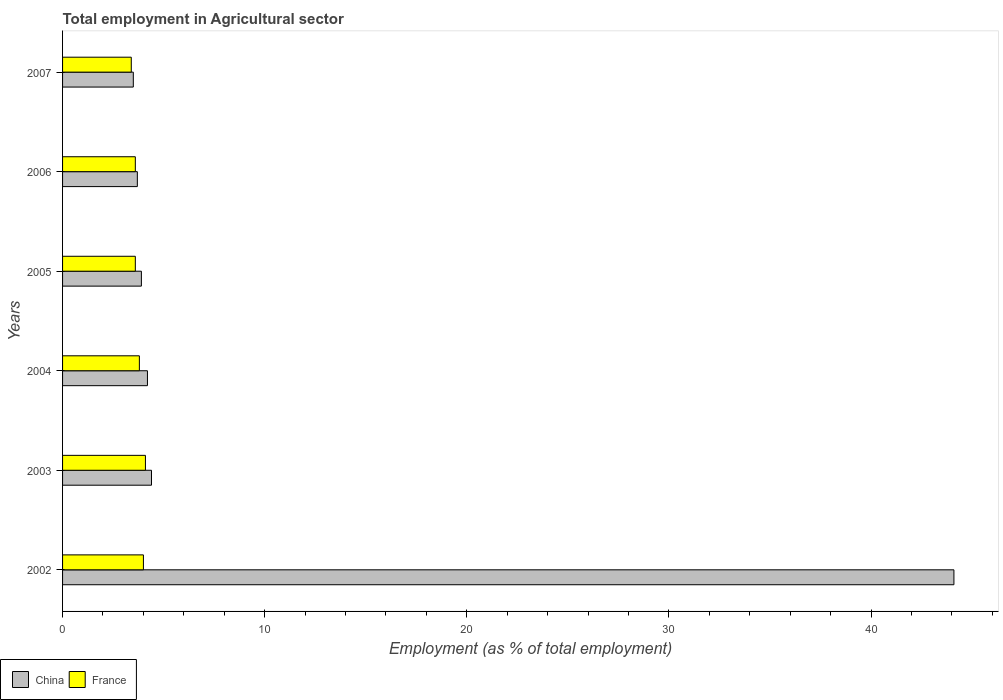How many different coloured bars are there?
Provide a short and direct response. 2. How many groups of bars are there?
Make the answer very short. 6. How many bars are there on the 6th tick from the top?
Make the answer very short. 2. How many bars are there on the 2nd tick from the bottom?
Offer a very short reply. 2. What is the label of the 3rd group of bars from the top?
Your answer should be very brief. 2005. In how many cases, is the number of bars for a given year not equal to the number of legend labels?
Keep it short and to the point. 0. What is the employment in agricultural sector in China in 2002?
Provide a short and direct response. 44.1. Across all years, what is the maximum employment in agricultural sector in France?
Offer a terse response. 4.1. Across all years, what is the minimum employment in agricultural sector in China?
Your answer should be very brief. 3.5. In which year was the employment in agricultural sector in France minimum?
Offer a very short reply. 2007. What is the total employment in agricultural sector in France in the graph?
Give a very brief answer. 22.5. What is the difference between the employment in agricultural sector in France in 2002 and that in 2005?
Your answer should be compact. 0.4. What is the difference between the employment in agricultural sector in France in 2007 and the employment in agricultural sector in China in 2002?
Keep it short and to the point. -40.7. What is the average employment in agricultural sector in China per year?
Ensure brevity in your answer.  10.63. In the year 2007, what is the difference between the employment in agricultural sector in France and employment in agricultural sector in China?
Your answer should be very brief. -0.1. What is the ratio of the employment in agricultural sector in China in 2004 to that in 2006?
Your response must be concise. 1.14. Is the employment in agricultural sector in France in 2005 less than that in 2006?
Offer a terse response. No. Is the difference between the employment in agricultural sector in France in 2006 and 2007 greater than the difference between the employment in agricultural sector in China in 2006 and 2007?
Offer a very short reply. No. What is the difference between the highest and the second highest employment in agricultural sector in China?
Offer a very short reply. 39.7. What is the difference between the highest and the lowest employment in agricultural sector in France?
Make the answer very short. 0.7. Is the sum of the employment in agricultural sector in France in 2002 and 2003 greater than the maximum employment in agricultural sector in China across all years?
Offer a very short reply. No. What does the 1st bar from the bottom in 2005 represents?
Offer a very short reply. China. Are the values on the major ticks of X-axis written in scientific E-notation?
Provide a succinct answer. No. Does the graph contain grids?
Your answer should be very brief. No. Where does the legend appear in the graph?
Offer a terse response. Bottom left. How many legend labels are there?
Keep it short and to the point. 2. How are the legend labels stacked?
Provide a succinct answer. Horizontal. What is the title of the graph?
Offer a very short reply. Total employment in Agricultural sector. Does "Latin America(all income levels)" appear as one of the legend labels in the graph?
Make the answer very short. No. What is the label or title of the X-axis?
Ensure brevity in your answer.  Employment (as % of total employment). What is the Employment (as % of total employment) of China in 2002?
Your answer should be compact. 44.1. What is the Employment (as % of total employment) of China in 2003?
Provide a succinct answer. 4.4. What is the Employment (as % of total employment) of France in 2003?
Give a very brief answer. 4.1. What is the Employment (as % of total employment) of China in 2004?
Give a very brief answer. 4.2. What is the Employment (as % of total employment) in France in 2004?
Offer a very short reply. 3.8. What is the Employment (as % of total employment) of China in 2005?
Provide a short and direct response. 3.9. What is the Employment (as % of total employment) of France in 2005?
Provide a short and direct response. 3.6. What is the Employment (as % of total employment) of China in 2006?
Provide a short and direct response. 3.7. What is the Employment (as % of total employment) of France in 2006?
Keep it short and to the point. 3.6. What is the Employment (as % of total employment) in China in 2007?
Your answer should be very brief. 3.5. What is the Employment (as % of total employment) of France in 2007?
Make the answer very short. 3.4. Across all years, what is the maximum Employment (as % of total employment) of China?
Offer a terse response. 44.1. Across all years, what is the maximum Employment (as % of total employment) of France?
Your answer should be compact. 4.1. Across all years, what is the minimum Employment (as % of total employment) in China?
Offer a very short reply. 3.5. Across all years, what is the minimum Employment (as % of total employment) of France?
Ensure brevity in your answer.  3.4. What is the total Employment (as % of total employment) of China in the graph?
Offer a terse response. 63.8. What is the total Employment (as % of total employment) of France in the graph?
Keep it short and to the point. 22.5. What is the difference between the Employment (as % of total employment) of China in 2002 and that in 2003?
Your response must be concise. 39.7. What is the difference between the Employment (as % of total employment) of France in 2002 and that in 2003?
Provide a succinct answer. -0.1. What is the difference between the Employment (as % of total employment) in China in 2002 and that in 2004?
Your answer should be very brief. 39.9. What is the difference between the Employment (as % of total employment) of France in 2002 and that in 2004?
Your answer should be compact. 0.2. What is the difference between the Employment (as % of total employment) of China in 2002 and that in 2005?
Provide a short and direct response. 40.2. What is the difference between the Employment (as % of total employment) of China in 2002 and that in 2006?
Make the answer very short. 40.4. What is the difference between the Employment (as % of total employment) in China in 2002 and that in 2007?
Make the answer very short. 40.6. What is the difference between the Employment (as % of total employment) in France in 2002 and that in 2007?
Offer a terse response. 0.6. What is the difference between the Employment (as % of total employment) of France in 2003 and that in 2004?
Your response must be concise. 0.3. What is the difference between the Employment (as % of total employment) in China in 2003 and that in 2006?
Give a very brief answer. 0.7. What is the difference between the Employment (as % of total employment) in China in 2003 and that in 2007?
Your answer should be compact. 0.9. What is the difference between the Employment (as % of total employment) of France in 2003 and that in 2007?
Offer a very short reply. 0.7. What is the difference between the Employment (as % of total employment) in France in 2004 and that in 2005?
Your response must be concise. 0.2. What is the difference between the Employment (as % of total employment) in China in 2004 and that in 2006?
Your response must be concise. 0.5. What is the difference between the Employment (as % of total employment) in China in 2005 and that in 2006?
Keep it short and to the point. 0.2. What is the difference between the Employment (as % of total employment) in China in 2005 and that in 2007?
Provide a succinct answer. 0.4. What is the difference between the Employment (as % of total employment) of France in 2005 and that in 2007?
Keep it short and to the point. 0.2. What is the difference between the Employment (as % of total employment) of China in 2006 and that in 2007?
Your answer should be very brief. 0.2. What is the difference between the Employment (as % of total employment) in France in 2006 and that in 2007?
Offer a very short reply. 0.2. What is the difference between the Employment (as % of total employment) in China in 2002 and the Employment (as % of total employment) in France in 2003?
Give a very brief answer. 40. What is the difference between the Employment (as % of total employment) of China in 2002 and the Employment (as % of total employment) of France in 2004?
Your answer should be compact. 40.3. What is the difference between the Employment (as % of total employment) in China in 2002 and the Employment (as % of total employment) in France in 2005?
Your response must be concise. 40.5. What is the difference between the Employment (as % of total employment) in China in 2002 and the Employment (as % of total employment) in France in 2006?
Your answer should be very brief. 40.5. What is the difference between the Employment (as % of total employment) of China in 2002 and the Employment (as % of total employment) of France in 2007?
Provide a short and direct response. 40.7. What is the difference between the Employment (as % of total employment) in China in 2003 and the Employment (as % of total employment) in France in 2004?
Your answer should be compact. 0.6. What is the difference between the Employment (as % of total employment) in China in 2003 and the Employment (as % of total employment) in France in 2007?
Offer a terse response. 1. What is the difference between the Employment (as % of total employment) in China in 2004 and the Employment (as % of total employment) in France in 2006?
Offer a terse response. 0.6. What is the difference between the Employment (as % of total employment) in China in 2005 and the Employment (as % of total employment) in France in 2006?
Keep it short and to the point. 0.3. What is the difference between the Employment (as % of total employment) in China in 2005 and the Employment (as % of total employment) in France in 2007?
Offer a very short reply. 0.5. What is the average Employment (as % of total employment) of China per year?
Offer a terse response. 10.63. What is the average Employment (as % of total employment) of France per year?
Give a very brief answer. 3.75. In the year 2002, what is the difference between the Employment (as % of total employment) of China and Employment (as % of total employment) of France?
Keep it short and to the point. 40.1. In the year 2004, what is the difference between the Employment (as % of total employment) in China and Employment (as % of total employment) in France?
Provide a succinct answer. 0.4. In the year 2006, what is the difference between the Employment (as % of total employment) in China and Employment (as % of total employment) in France?
Provide a succinct answer. 0.1. In the year 2007, what is the difference between the Employment (as % of total employment) in China and Employment (as % of total employment) in France?
Keep it short and to the point. 0.1. What is the ratio of the Employment (as % of total employment) of China in 2002 to that in 2003?
Provide a succinct answer. 10.02. What is the ratio of the Employment (as % of total employment) of France in 2002 to that in 2003?
Provide a short and direct response. 0.98. What is the ratio of the Employment (as % of total employment) in China in 2002 to that in 2004?
Offer a terse response. 10.5. What is the ratio of the Employment (as % of total employment) of France in 2002 to that in 2004?
Keep it short and to the point. 1.05. What is the ratio of the Employment (as % of total employment) in China in 2002 to that in 2005?
Provide a succinct answer. 11.31. What is the ratio of the Employment (as % of total employment) in China in 2002 to that in 2006?
Offer a very short reply. 11.92. What is the ratio of the Employment (as % of total employment) of China in 2002 to that in 2007?
Your answer should be compact. 12.6. What is the ratio of the Employment (as % of total employment) of France in 2002 to that in 2007?
Your response must be concise. 1.18. What is the ratio of the Employment (as % of total employment) in China in 2003 to that in 2004?
Keep it short and to the point. 1.05. What is the ratio of the Employment (as % of total employment) in France in 2003 to that in 2004?
Provide a succinct answer. 1.08. What is the ratio of the Employment (as % of total employment) in China in 2003 to that in 2005?
Offer a terse response. 1.13. What is the ratio of the Employment (as % of total employment) of France in 2003 to that in 2005?
Ensure brevity in your answer.  1.14. What is the ratio of the Employment (as % of total employment) of China in 2003 to that in 2006?
Provide a short and direct response. 1.19. What is the ratio of the Employment (as % of total employment) of France in 2003 to that in 2006?
Make the answer very short. 1.14. What is the ratio of the Employment (as % of total employment) in China in 2003 to that in 2007?
Keep it short and to the point. 1.26. What is the ratio of the Employment (as % of total employment) of France in 2003 to that in 2007?
Give a very brief answer. 1.21. What is the ratio of the Employment (as % of total employment) in China in 2004 to that in 2005?
Give a very brief answer. 1.08. What is the ratio of the Employment (as % of total employment) of France in 2004 to that in 2005?
Your response must be concise. 1.06. What is the ratio of the Employment (as % of total employment) in China in 2004 to that in 2006?
Offer a terse response. 1.14. What is the ratio of the Employment (as % of total employment) of France in 2004 to that in 2006?
Provide a succinct answer. 1.06. What is the ratio of the Employment (as % of total employment) in France in 2004 to that in 2007?
Keep it short and to the point. 1.12. What is the ratio of the Employment (as % of total employment) of China in 2005 to that in 2006?
Offer a very short reply. 1.05. What is the ratio of the Employment (as % of total employment) of China in 2005 to that in 2007?
Give a very brief answer. 1.11. What is the ratio of the Employment (as % of total employment) of France in 2005 to that in 2007?
Offer a terse response. 1.06. What is the ratio of the Employment (as % of total employment) in China in 2006 to that in 2007?
Make the answer very short. 1.06. What is the ratio of the Employment (as % of total employment) in France in 2006 to that in 2007?
Your answer should be very brief. 1.06. What is the difference between the highest and the second highest Employment (as % of total employment) of China?
Provide a succinct answer. 39.7. What is the difference between the highest and the second highest Employment (as % of total employment) of France?
Provide a short and direct response. 0.1. What is the difference between the highest and the lowest Employment (as % of total employment) in China?
Give a very brief answer. 40.6. What is the difference between the highest and the lowest Employment (as % of total employment) of France?
Provide a succinct answer. 0.7. 